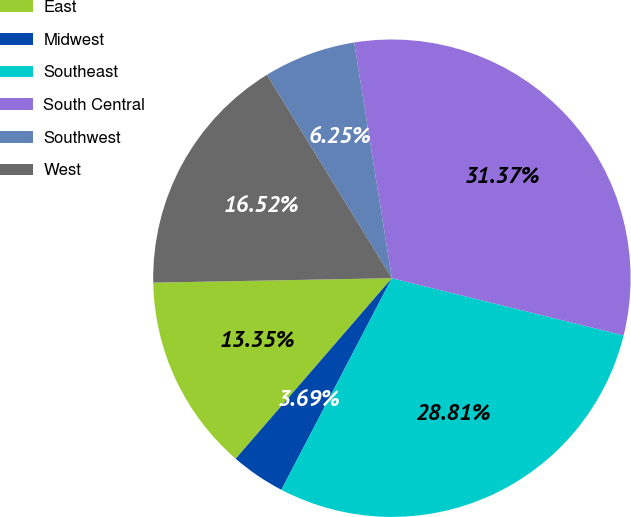Convert chart to OTSL. <chart><loc_0><loc_0><loc_500><loc_500><pie_chart><fcel>East<fcel>Midwest<fcel>Southeast<fcel>South Central<fcel>Southwest<fcel>West<nl><fcel>13.35%<fcel>3.69%<fcel>28.81%<fcel>31.37%<fcel>6.25%<fcel>16.52%<nl></chart> 